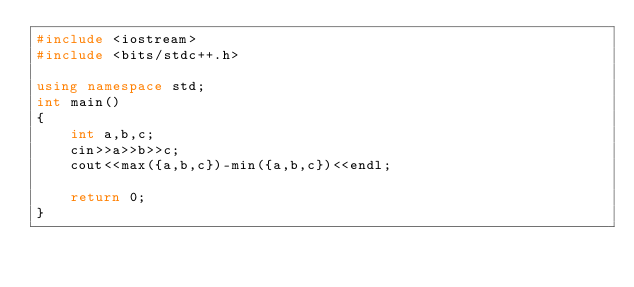Convert code to text. <code><loc_0><loc_0><loc_500><loc_500><_C++_>#include <iostream>
#include <bits/stdc++.h>

using namespace std;
int main()
{
    int a,b,c;
    cin>>a>>b>>c;
    cout<<max({a,b,c})-min({a,b,c})<<endl;

    return 0;
}
</code> 